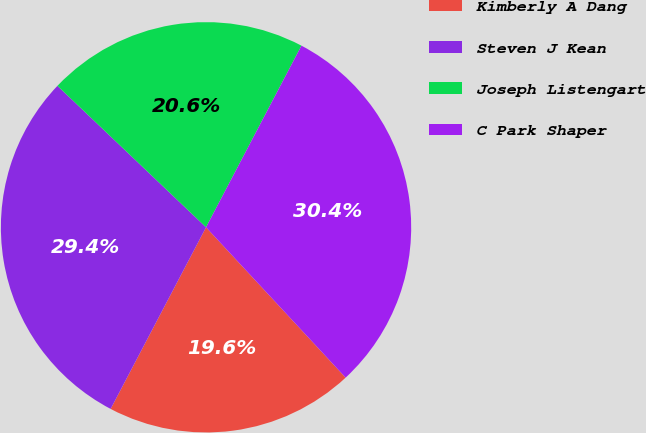Convert chart. <chart><loc_0><loc_0><loc_500><loc_500><pie_chart><fcel>Kimberly A Dang<fcel>Steven J Kean<fcel>Joseph Listengart<fcel>C Park Shaper<nl><fcel>19.61%<fcel>29.41%<fcel>20.59%<fcel>30.39%<nl></chart> 